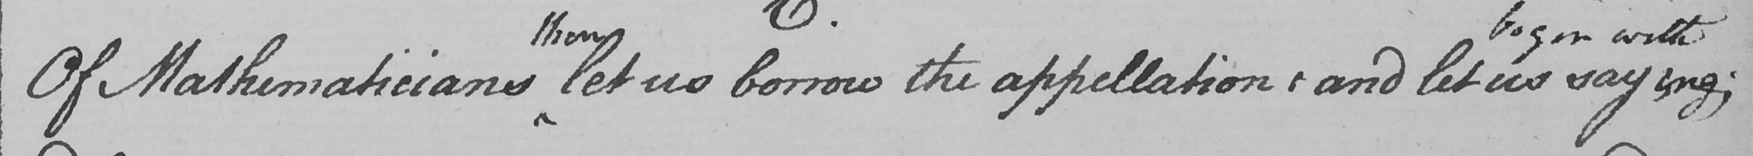Please transcribe the handwritten text in this image. Of Mathematicians let us borrow the appellation :  and let us saying ; 